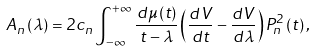Convert formula to latex. <formula><loc_0><loc_0><loc_500><loc_500>A _ { n } \left ( \lambda \right ) = 2 c _ { n } \int _ { - \infty } ^ { + \infty } \frac { d \mu \left ( t \right ) } { t - \lambda } \left ( \frac { d V } { d t } - \frac { d V } { d \lambda } \right ) P _ { n } ^ { 2 } \left ( t \right ) ,</formula> 